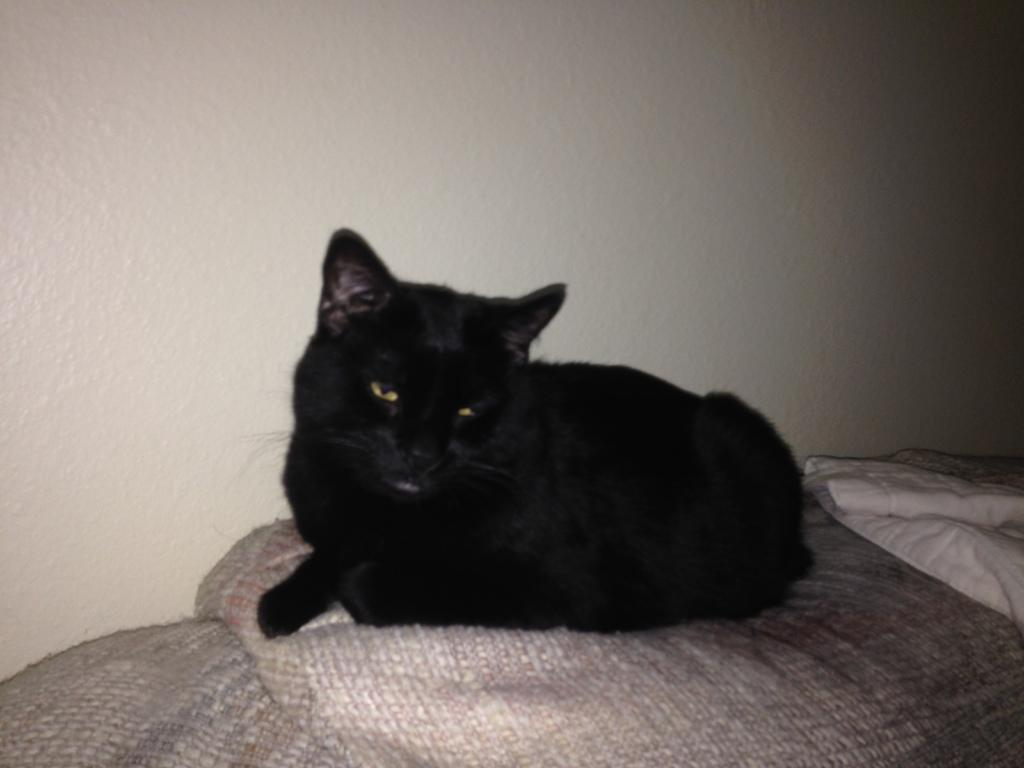What type of animal is in the image? There is a black color cat in the image. What is located beside the cat in the image? There is a wall beside the cat in the image. What invention is being demonstrated by the cat in the image? There is no invention being demonstrated by the cat in the image; it is simply a cat sitting beside a wall. 